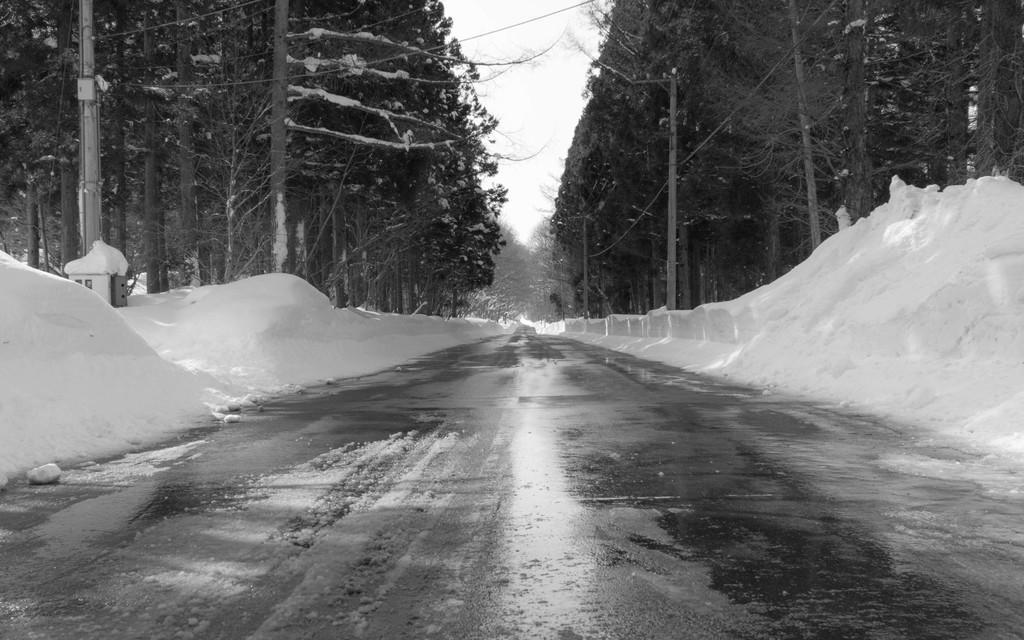Please provide a concise description of this image. In this image we can see black and white picture of a group of trees, poles, pathway and in the background we can see the sky. 